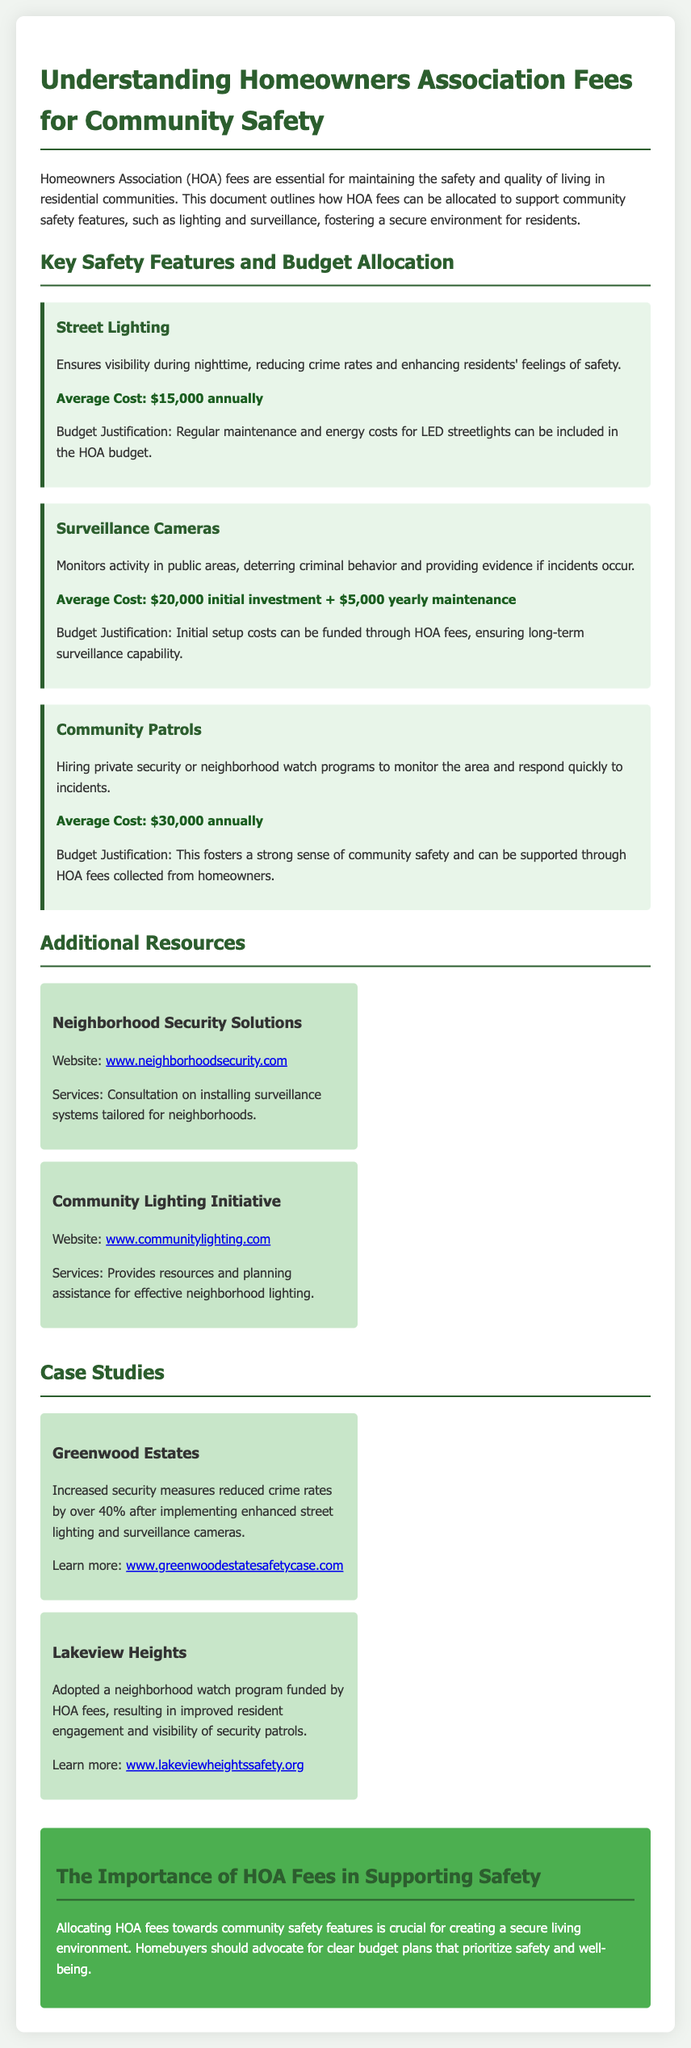What is the average cost for street lighting? The average cost for street lighting is stated as $15,000 annually.
Answer: $15,000 annually What is the initial investment for surveillance cameras? The document specifies that the initial investment for surveillance cameras is $20,000.
Answer: $20,000 How much do community patrols cost annually? The cost for community patrols is detailed as $30,000 annually.
Answer: $30,000 annually What is one benefit of installing street lighting? The document mentions that street lighting enhances residents' feelings of safety.
Answer: Enhances residents' feelings of safety What is the primary purpose of surveillance cameras? Surveillance cameras are used to monitor activity in public areas.
Answer: Monitor activity in public areas What program has been adopted by Lakeview Heights? Lakeview Heights adopted a neighborhood watch program.
Answer: Neighborhood watch program Which organization provides resources for effective neighborhood lighting? The organization mentioned is the Community Lighting Initiative.
Answer: Community Lighting Initiative What type of solutions does Neighborhood Security Solutions offer? They offer consultation on installing surveillance systems tailored for neighborhoods.
Answer: Consultation on installing surveillance systems What percentage did crime rates decrease in Greenwood Estates after security measures? The crime rates decreased by over 40% after implementing enhanced security measures.
Answer: Over 40% 